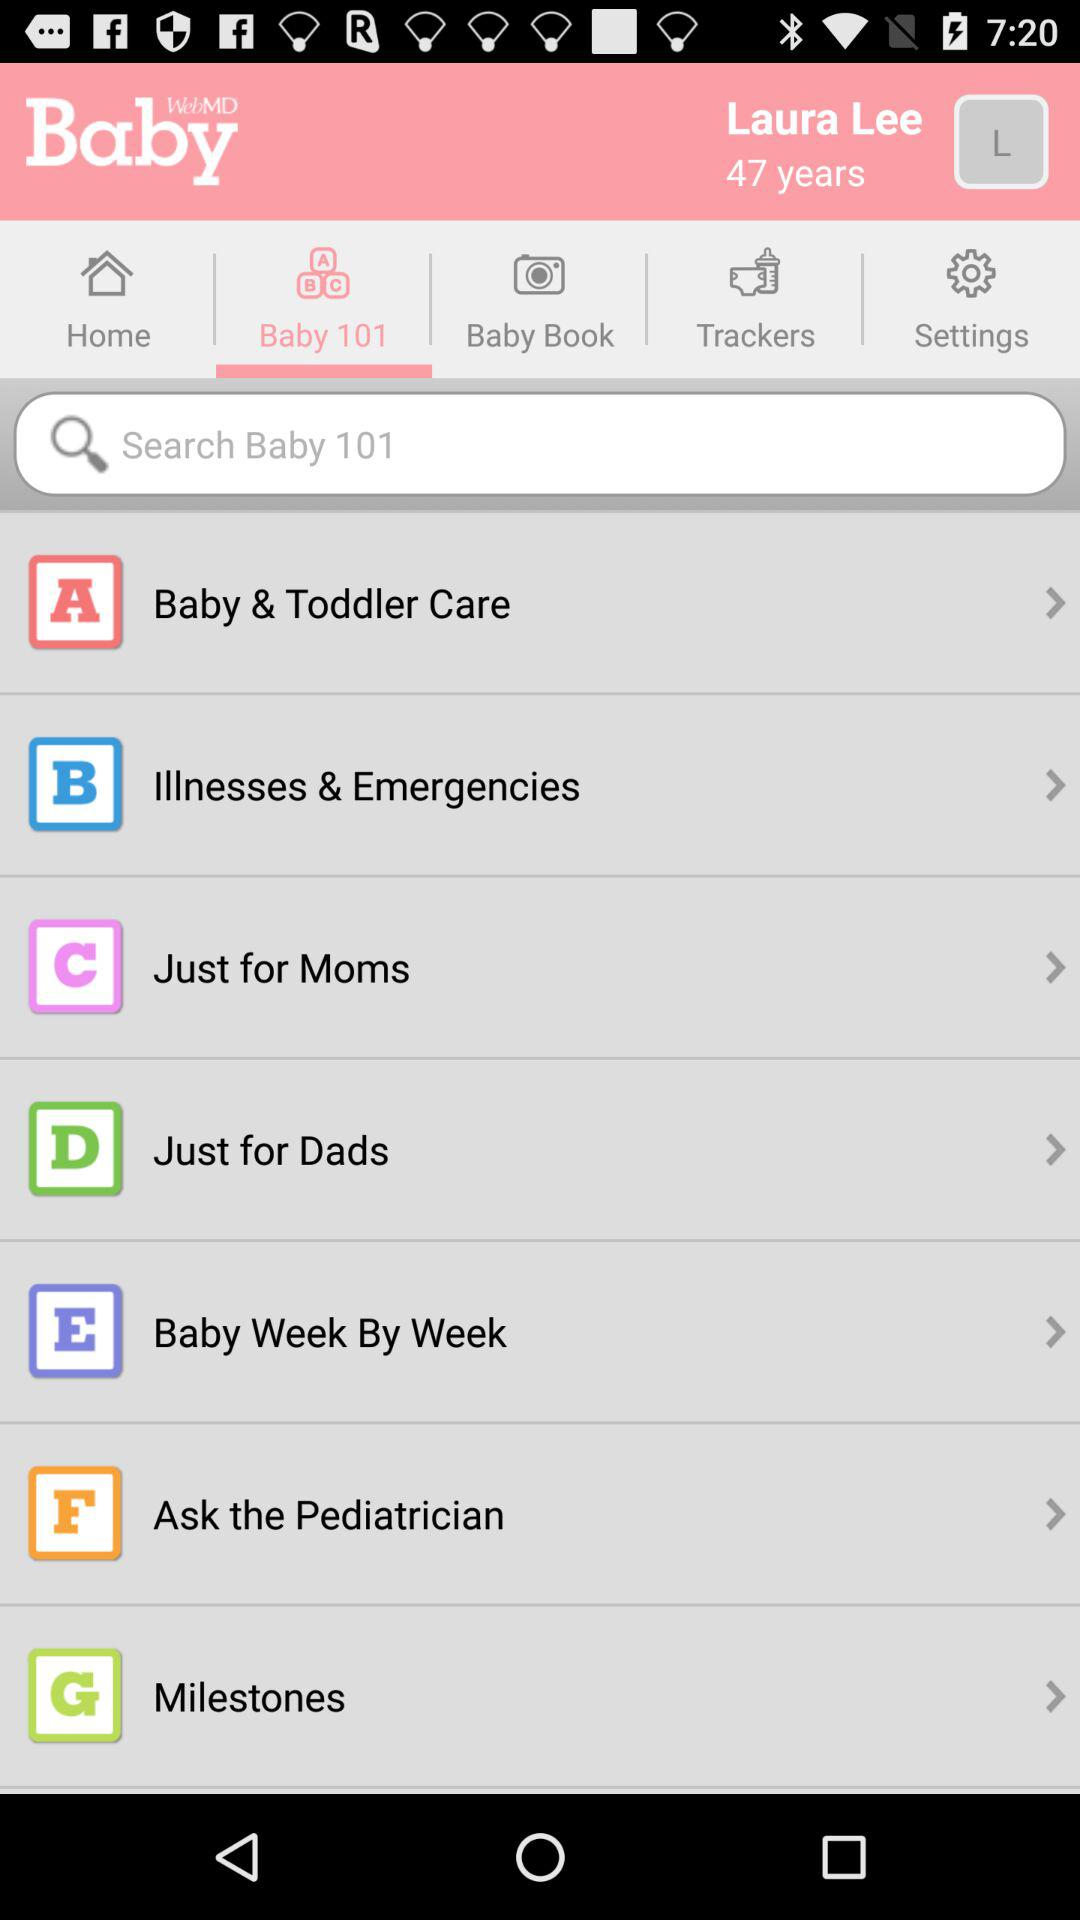What tab is selected? The selected tab is "Baby 101". 